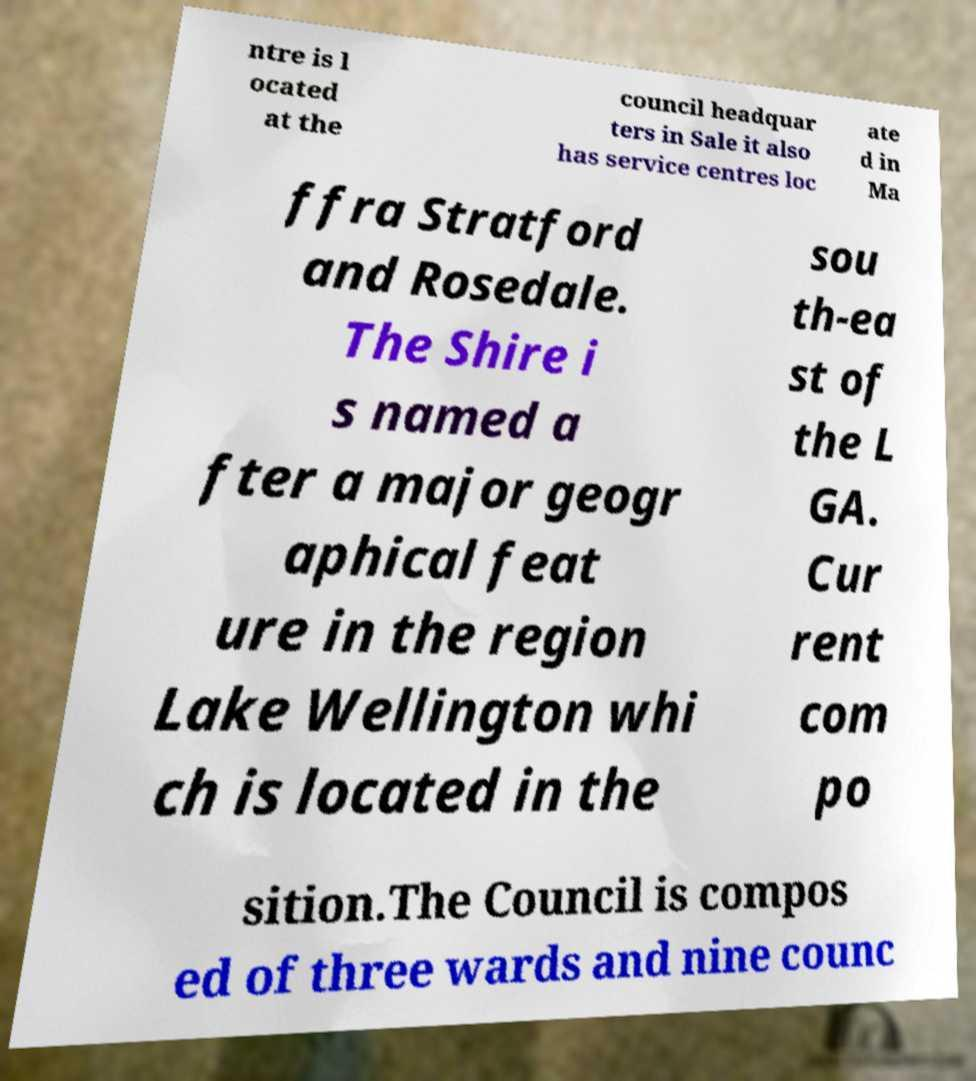Could you assist in decoding the text presented in this image and type it out clearly? ntre is l ocated at the council headquar ters in Sale it also has service centres loc ate d in Ma ffra Stratford and Rosedale. The Shire i s named a fter a major geogr aphical feat ure in the region Lake Wellington whi ch is located in the sou th-ea st of the L GA. Cur rent com po sition.The Council is compos ed of three wards and nine counc 